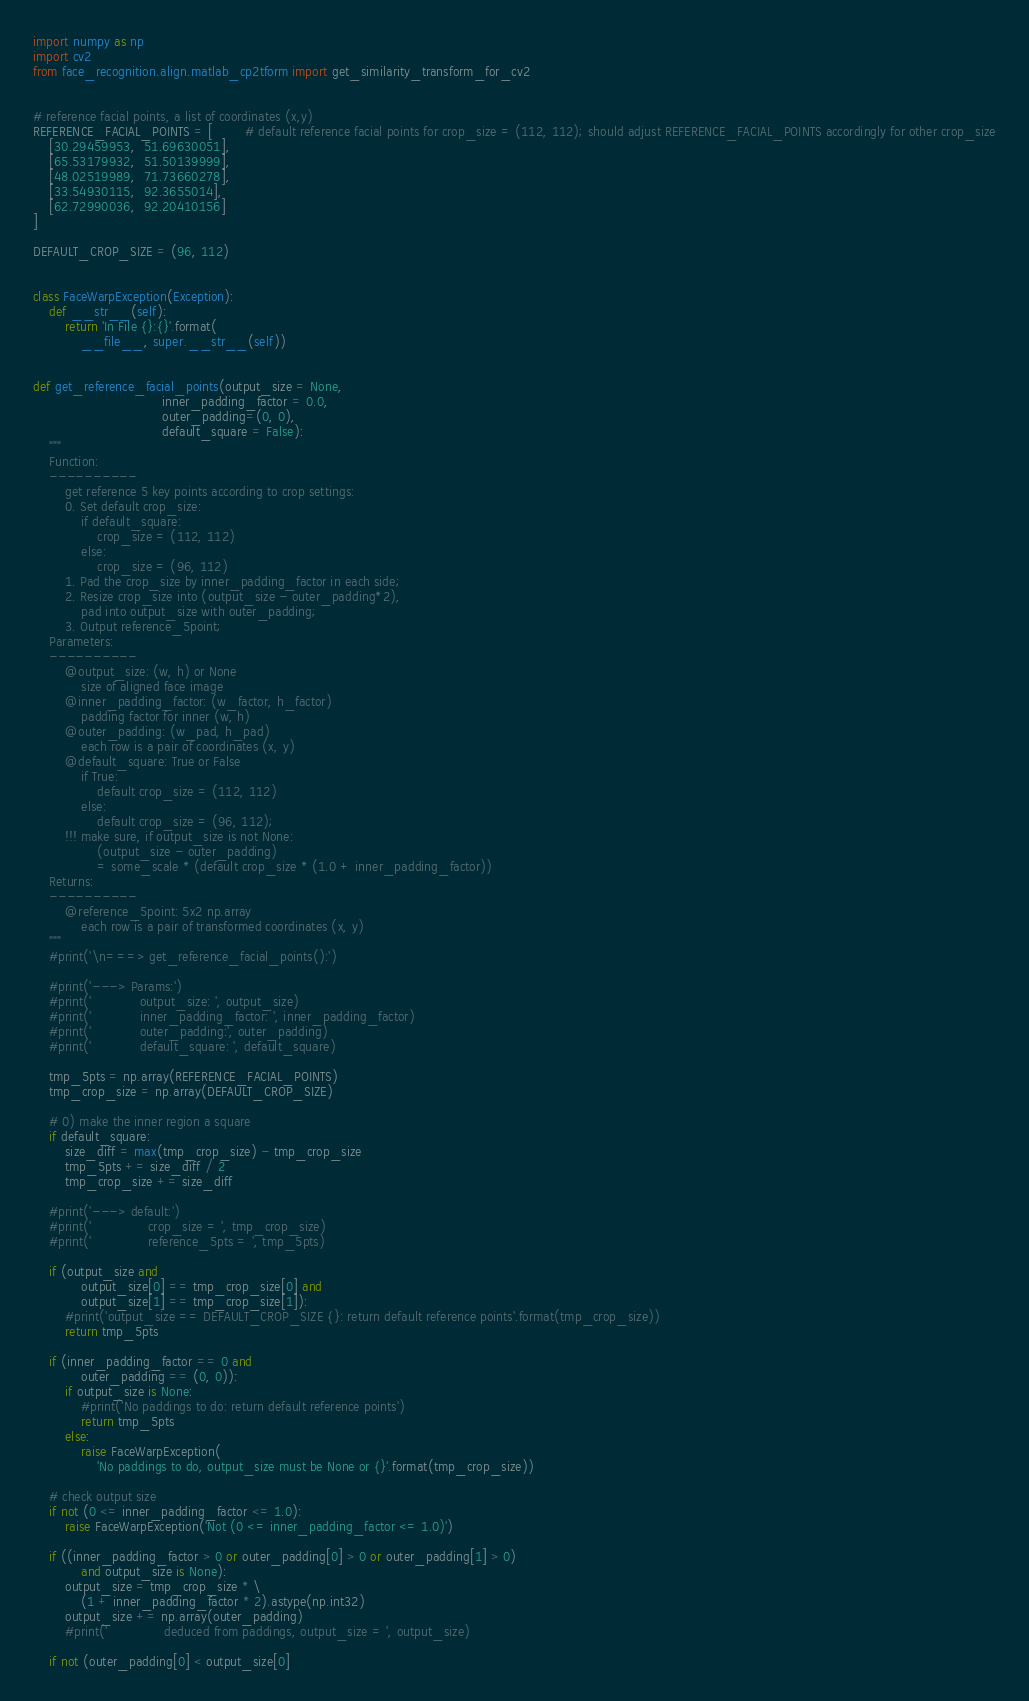<code> <loc_0><loc_0><loc_500><loc_500><_Python_>import numpy as np
import cv2
from face_recognition.align.matlab_cp2tform import get_similarity_transform_for_cv2


# reference facial points, a list of coordinates (x,y)
REFERENCE_FACIAL_POINTS = [        # default reference facial points for crop_size = (112, 112); should adjust REFERENCE_FACIAL_POINTS accordingly for other crop_size
    [30.29459953,  51.69630051], 
    [65.53179932,  51.50139999],
    [48.02519989,  71.73660278],
    [33.54930115,  92.3655014],
    [62.72990036,  92.20410156]
]

DEFAULT_CROP_SIZE = (96, 112)


class FaceWarpException(Exception):
    def __str__(self):
        return 'In File {}:{}'.format(
            __file__, super.__str__(self))


def get_reference_facial_points(output_size = None,
                                inner_padding_factor = 0.0,
                                outer_padding=(0, 0),
                                default_square = False):
    """
    Function:
    ----------
        get reference 5 key points according to crop settings:
        0. Set default crop_size:
            if default_square: 
                crop_size = (112, 112)
            else: 
                crop_size = (96, 112)
        1. Pad the crop_size by inner_padding_factor in each side;
        2. Resize crop_size into (output_size - outer_padding*2),
            pad into output_size with outer_padding;
        3. Output reference_5point;
    Parameters:
    ----------
        @output_size: (w, h) or None
            size of aligned face image
        @inner_padding_factor: (w_factor, h_factor)
            padding factor for inner (w, h)
        @outer_padding: (w_pad, h_pad)
            each row is a pair of coordinates (x, y)
        @default_square: True or False
            if True:
                default crop_size = (112, 112)
            else:
                default crop_size = (96, 112);
        !!! make sure, if output_size is not None:
                (output_size - outer_padding) 
                = some_scale * (default crop_size * (1.0 + inner_padding_factor))
    Returns:
    ----------
        @reference_5point: 5x2 np.array
            each row is a pair of transformed coordinates (x, y)
    """
    #print('\n===> get_reference_facial_points():')

    #print('---> Params:')
    #print('            output_size: ', output_size)
    #print('            inner_padding_factor: ', inner_padding_factor)
    #print('            outer_padding:', outer_padding)
    #print('            default_square: ', default_square)

    tmp_5pts = np.array(REFERENCE_FACIAL_POINTS)
    tmp_crop_size = np.array(DEFAULT_CROP_SIZE)

    # 0) make the inner region a square
    if default_square:
        size_diff = max(tmp_crop_size) - tmp_crop_size
        tmp_5pts += size_diff / 2
        tmp_crop_size += size_diff

    #print('---> default:')
    #print('              crop_size = ', tmp_crop_size)
    #print('              reference_5pts = ', tmp_5pts)

    if (output_size and
            output_size[0] == tmp_crop_size[0] and
            output_size[1] == tmp_crop_size[1]):
        #print('output_size == DEFAULT_CROP_SIZE {}: return default reference points'.format(tmp_crop_size))
        return tmp_5pts

    if (inner_padding_factor == 0 and
            outer_padding == (0, 0)):
        if output_size is None:
            #print('No paddings to do: return default reference points')
            return tmp_5pts
        else:
            raise FaceWarpException(
                'No paddings to do, output_size must be None or {}'.format(tmp_crop_size))

    # check output size
    if not (0 <= inner_padding_factor <= 1.0):
        raise FaceWarpException('Not (0 <= inner_padding_factor <= 1.0)')

    if ((inner_padding_factor > 0 or outer_padding[0] > 0 or outer_padding[1] > 0)
            and output_size is None):
        output_size = tmp_crop_size * \
            (1 + inner_padding_factor * 2).astype(np.int32)
        output_size += np.array(outer_padding)
        #print('              deduced from paddings, output_size = ', output_size)

    if not (outer_padding[0] < output_size[0]</code> 